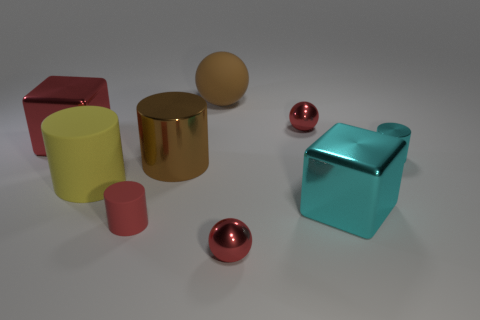Is the number of small metallic objects that are behind the yellow thing greater than the number of red cylinders? Indeed, the quantity of smaller metallic spheres located behind the sizable yellow cylinder surpasses the tally of red cylinders present, which are two in number. 